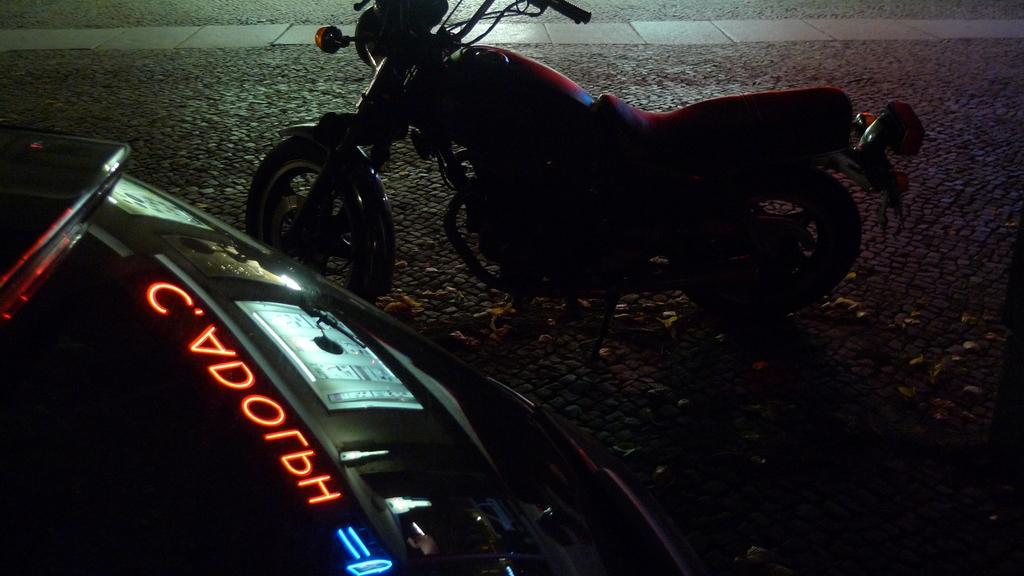Could you give a brief overview of what you see in this image? In this image we can see a vehicle. In the background of the image there is a floor and other objects. On the left side of the image there is another vehicle. 